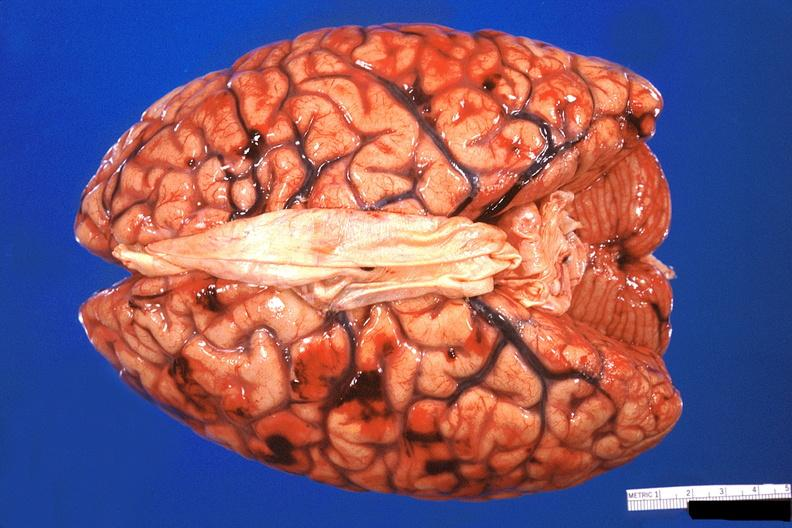s nervous present?
Answer the question using a single word or phrase. Yes 